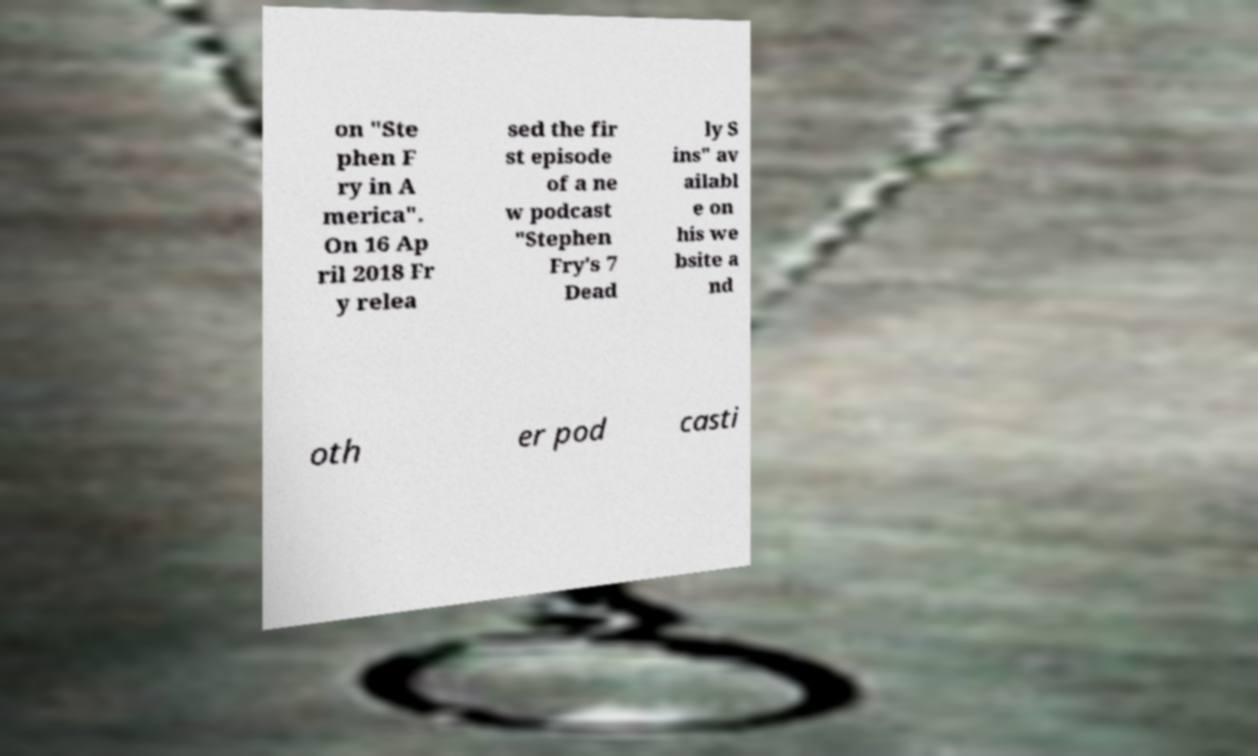Please identify and transcribe the text found in this image. on "Ste phen F ry in A merica". On 16 Ap ril 2018 Fr y relea sed the fir st episode of a ne w podcast "Stephen Fry's 7 Dead ly S ins" av ailabl e on his we bsite a nd oth er pod casti 